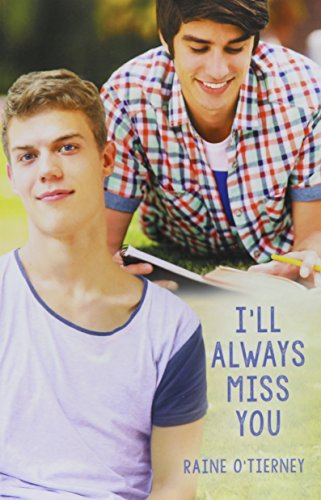Can you tell me more about the main themes explored in this book? This book explores deep themes like loss, friendship, and the process of healing which are particularly impactful and relevant to young adult readers. 